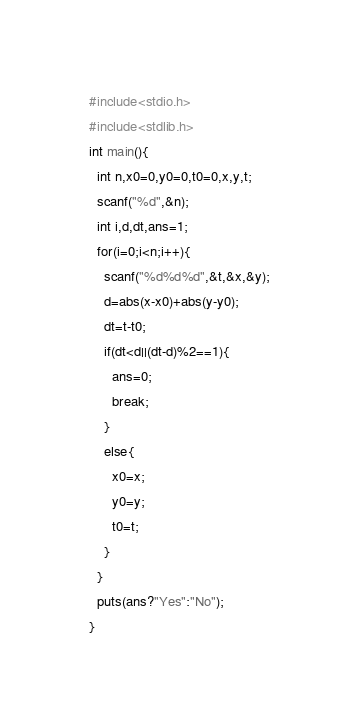<code> <loc_0><loc_0><loc_500><loc_500><_C_>#include<stdio.h>
#include<stdlib.h>
int main(){
  int n,x0=0,y0=0,t0=0,x,y,t;
  scanf("%d",&n);
  int i,d,dt,ans=1;
  for(i=0;i<n;i++){
    scanf("%d%d%d",&t,&x,&y);
    d=abs(x-x0)+abs(y-y0);
    dt=t-t0;
    if(dt<d||(dt-d)%2==1){
      ans=0;
      break;
    }
    else{
      x0=x;
      y0=y;
      t0=t;
    }
  }
  puts(ans?"Yes":"No");
}</code> 